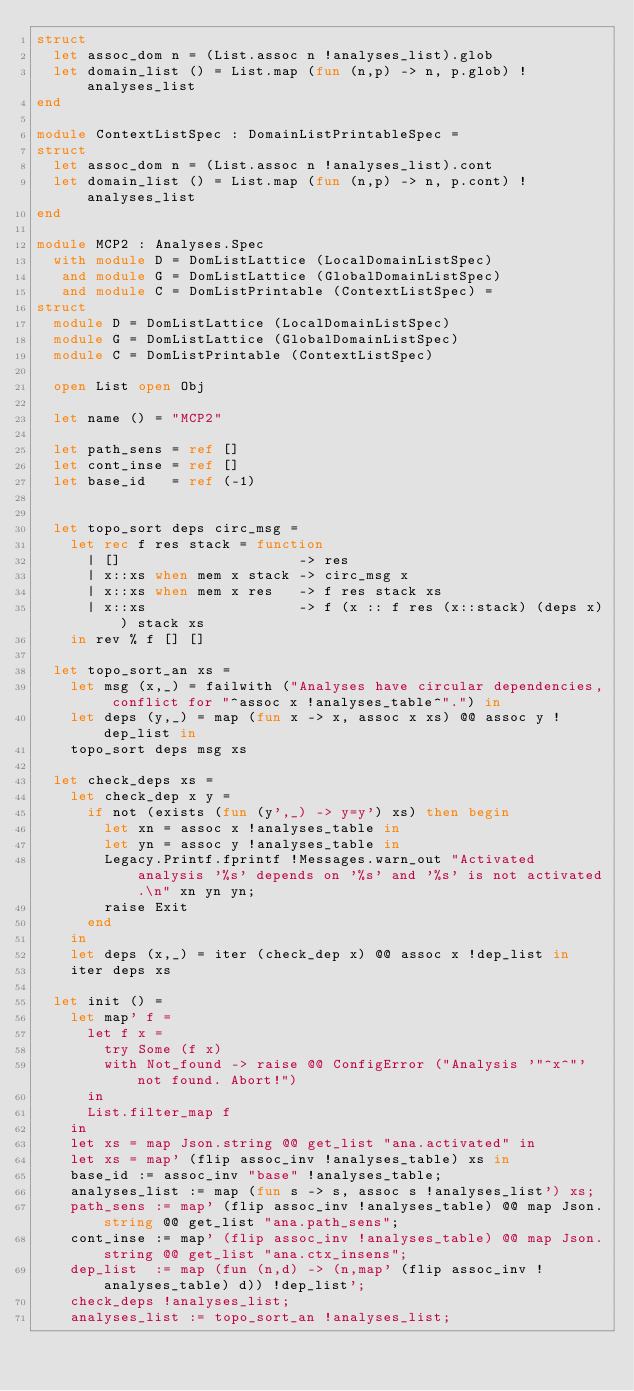Convert code to text. <code><loc_0><loc_0><loc_500><loc_500><_OCaml_>struct
  let assoc_dom n = (List.assoc n !analyses_list).glob
  let domain_list () = List.map (fun (n,p) -> n, p.glob) !analyses_list
end

module ContextListSpec : DomainListPrintableSpec =
struct
  let assoc_dom n = (List.assoc n !analyses_list).cont
  let domain_list () = List.map (fun (n,p) -> n, p.cont) !analyses_list
end

module MCP2 : Analyses.Spec
  with module D = DomListLattice (LocalDomainListSpec)
   and module G = DomListLattice (GlobalDomainListSpec)
   and module C = DomListPrintable (ContextListSpec) =
struct
  module D = DomListLattice (LocalDomainListSpec)
  module G = DomListLattice (GlobalDomainListSpec)
  module C = DomListPrintable (ContextListSpec)

  open List open Obj

  let name () = "MCP2"

  let path_sens = ref []
  let cont_inse = ref []
  let base_id   = ref (-1)


  let topo_sort deps circ_msg =
    let rec f res stack = function
      | []                     -> res
      | x::xs when mem x stack -> circ_msg x
      | x::xs when mem x res   -> f res stack xs
      | x::xs                  -> f (x :: f res (x::stack) (deps x)) stack xs
    in rev % f [] []

  let topo_sort_an xs =
    let msg (x,_) = failwith ("Analyses have circular dependencies, conflict for "^assoc x !analyses_table^".") in
    let deps (y,_) = map (fun x -> x, assoc x xs) @@ assoc y !dep_list in
    topo_sort deps msg xs

  let check_deps xs =
    let check_dep x y =
      if not (exists (fun (y',_) -> y=y') xs) then begin
        let xn = assoc x !analyses_table in
        let yn = assoc y !analyses_table in
        Legacy.Printf.fprintf !Messages.warn_out "Activated analysis '%s' depends on '%s' and '%s' is not activated.\n" xn yn yn;
        raise Exit
      end
    in
    let deps (x,_) = iter (check_dep x) @@ assoc x !dep_list in
    iter deps xs

  let init () =
    let map' f =
      let f x =
        try Some (f x)
        with Not_found -> raise @@ ConfigError ("Analysis '"^x^"' not found. Abort!")
      in
      List.filter_map f
    in
    let xs = map Json.string @@ get_list "ana.activated" in
    let xs = map' (flip assoc_inv !analyses_table) xs in
    base_id := assoc_inv "base" !analyses_table;
    analyses_list := map (fun s -> s, assoc s !analyses_list') xs;
    path_sens := map' (flip assoc_inv !analyses_table) @@ map Json.string @@ get_list "ana.path_sens";
    cont_inse := map' (flip assoc_inv !analyses_table) @@ map Json.string @@ get_list "ana.ctx_insens";
    dep_list  := map (fun (n,d) -> (n,map' (flip assoc_inv !analyses_table) d)) !dep_list';
    check_deps !analyses_list;
    analyses_list := topo_sort_an !analyses_list;</code> 